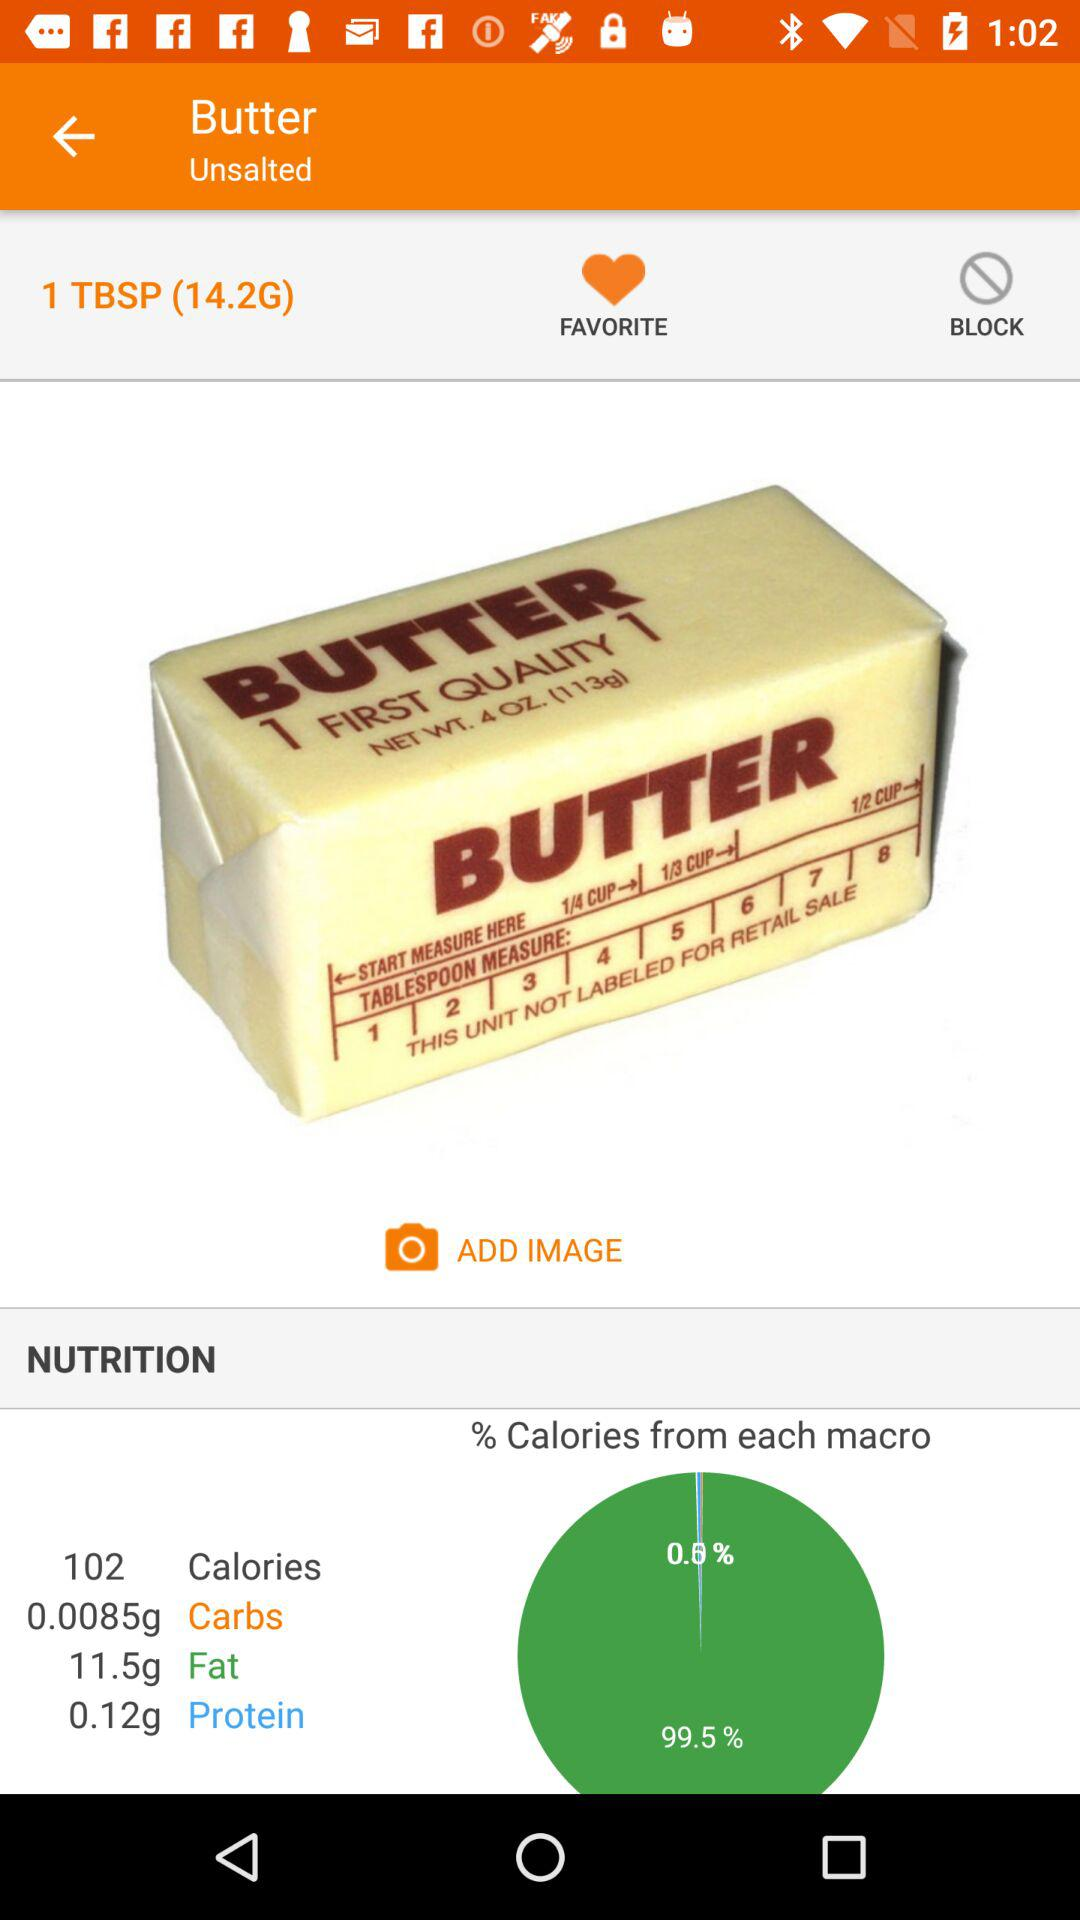How many calories are in 1 tablespoon of butter?
Answer the question using a single word or phrase. 102 